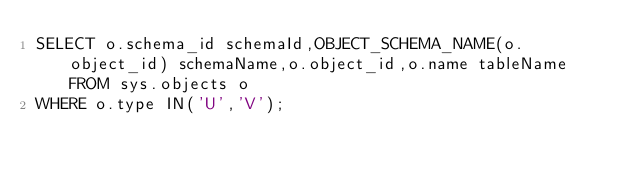<code> <loc_0><loc_0><loc_500><loc_500><_SQL_>SELECT o.schema_id schemaId,OBJECT_SCHEMA_NAME(o.object_id) schemaName,o.object_id,o.name tableName FROM sys.objects o 
WHERE o.type IN('U','V');</code> 